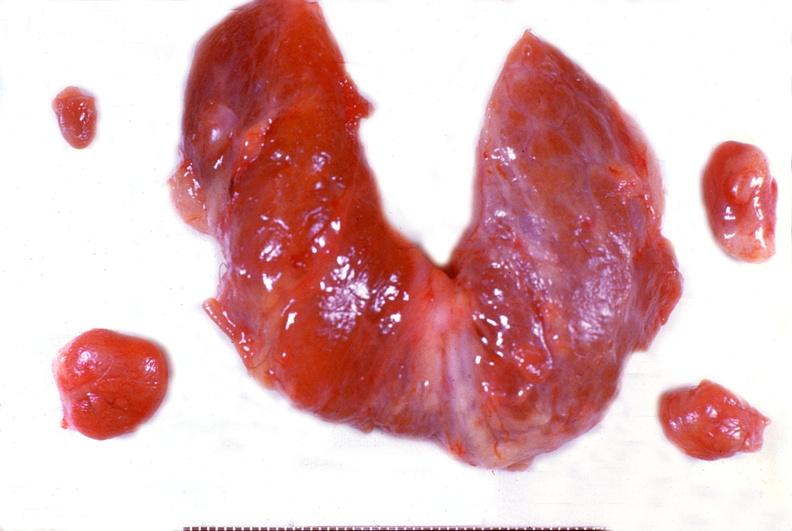s natural color present?
Answer the question using a single word or phrase. No 